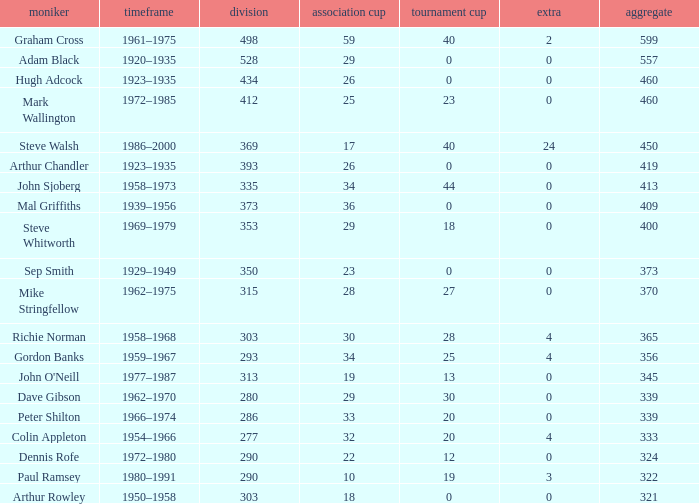What is the average number of FA cups Steve Whitworth, who has less than 400 total, has? None. 